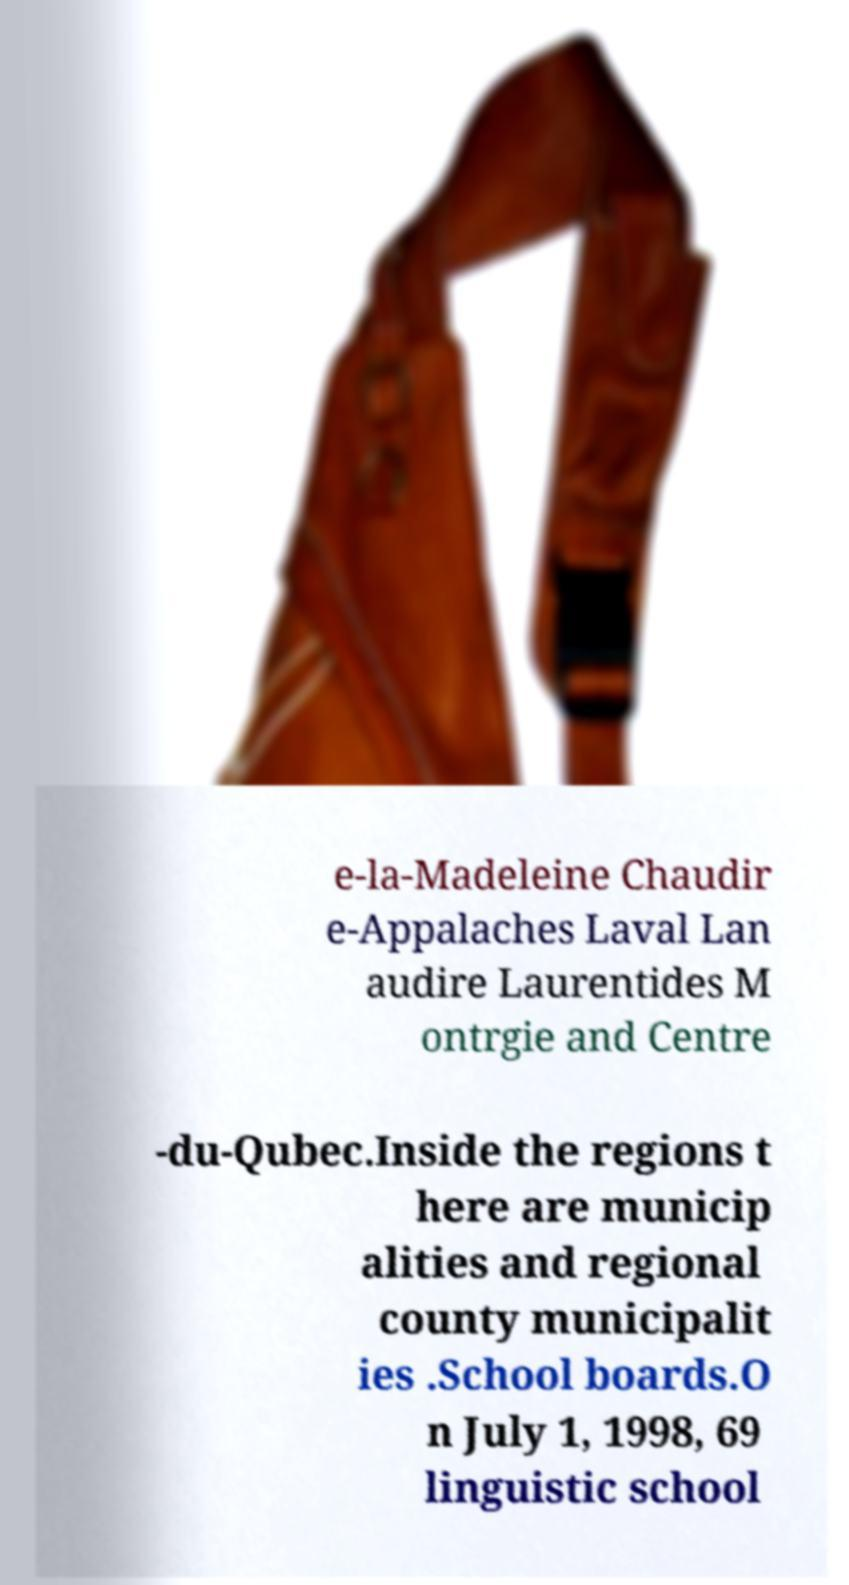Please identify and transcribe the text found in this image. e-la-Madeleine Chaudir e-Appalaches Laval Lan audire Laurentides M ontrgie and Centre -du-Qubec.Inside the regions t here are municip alities and regional county municipalit ies .School boards.O n July 1, 1998, 69 linguistic school 